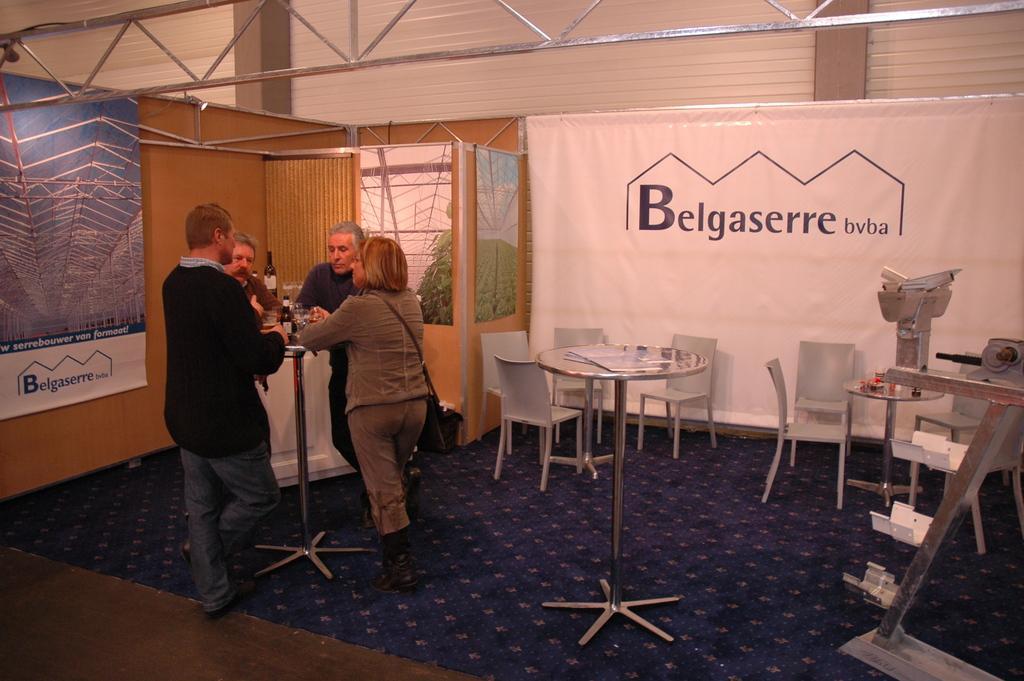Could you give a brief overview of what you see in this image? In this room there is a table on the left where four people are standing around discussing something, on the table there is a bottle. On the left there is a wooden board having blue hoarding and in the center there is a table. Many chairs are placed in the room. In the background there is a blue banner. There is a stand in the right corner. A woman is wearing a brown dress. This man is wearing a black sweater. 